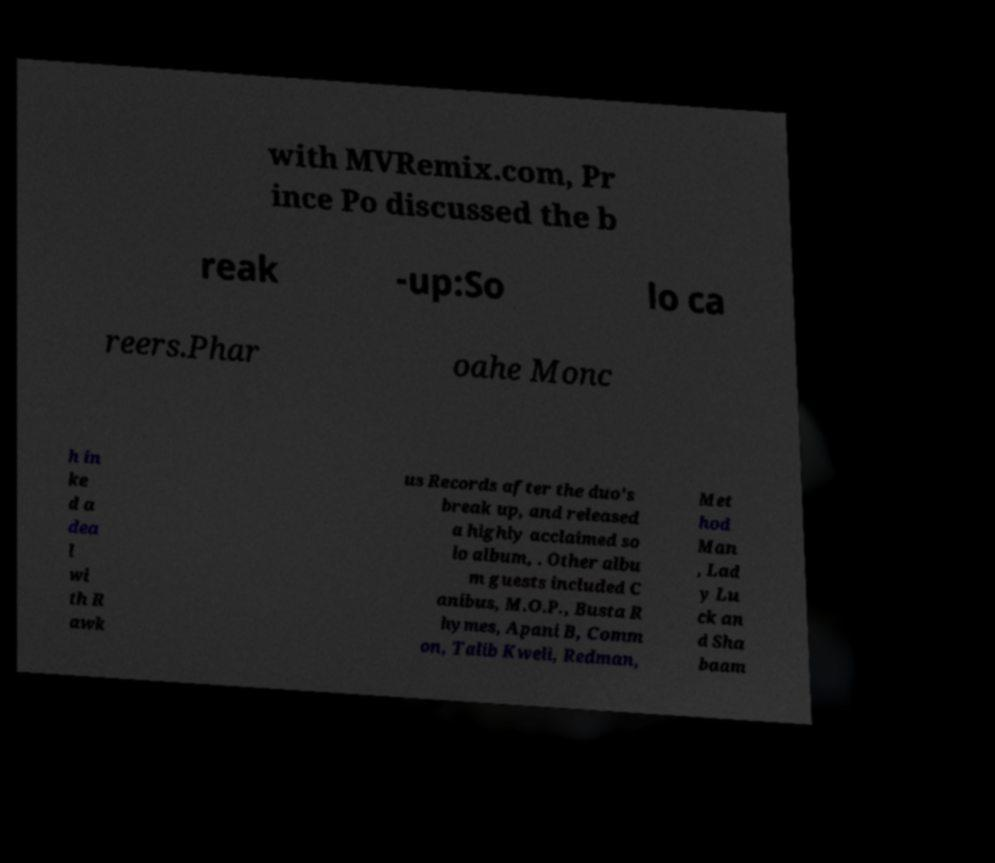Please read and relay the text visible in this image. What does it say? with MVRemix.com, Pr ince Po discussed the b reak -up:So lo ca reers.Phar oahe Monc h in ke d a dea l wi th R awk us Records after the duo's break up, and released a highly acclaimed so lo album, . Other albu m guests included C anibus, M.O.P., Busta R hymes, Apani B, Comm on, Talib Kweli, Redman, Met hod Man , Lad y Lu ck an d Sha baam 